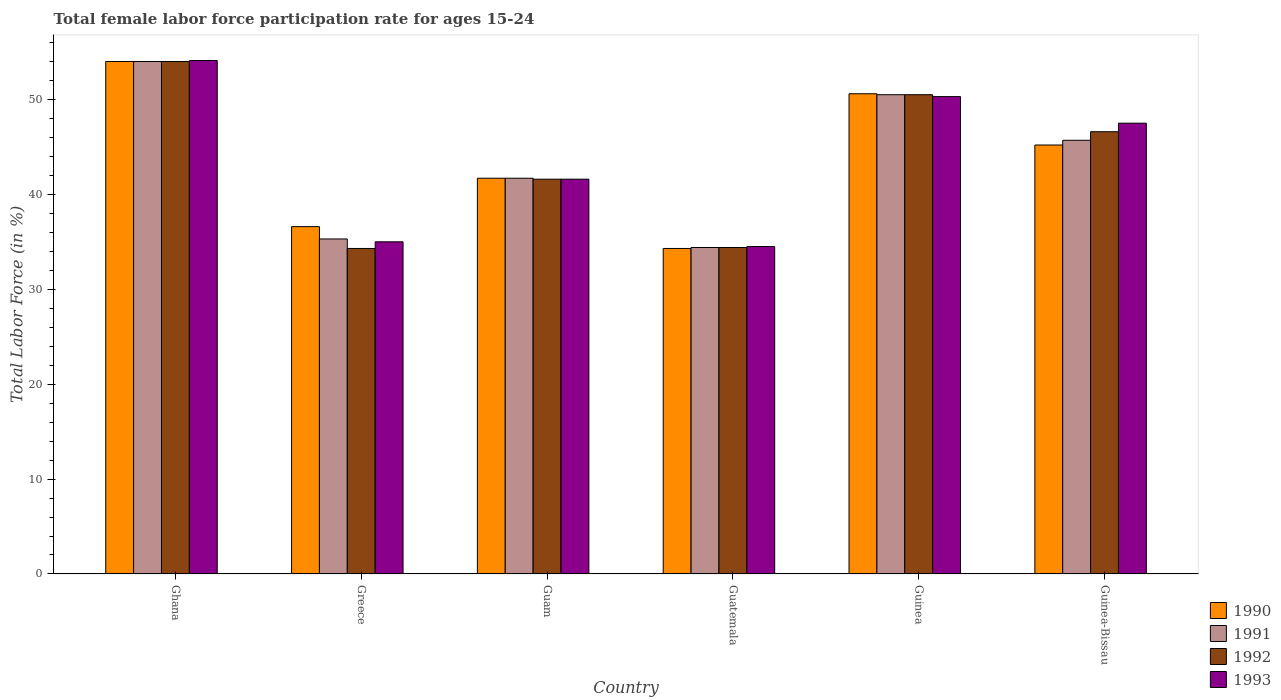How many bars are there on the 1st tick from the left?
Keep it short and to the point. 4. What is the female labor force participation rate in 1992 in Greece?
Ensure brevity in your answer.  34.3. Across all countries, what is the maximum female labor force participation rate in 1991?
Provide a short and direct response. 54. Across all countries, what is the minimum female labor force participation rate in 1990?
Give a very brief answer. 34.3. In which country was the female labor force participation rate in 1990 minimum?
Offer a terse response. Guatemala. What is the total female labor force participation rate in 1990 in the graph?
Offer a very short reply. 262.4. What is the difference between the female labor force participation rate in 1993 in Greece and that in Guam?
Offer a terse response. -6.6. What is the difference between the female labor force participation rate in 1990 in Guatemala and the female labor force participation rate in 1991 in Guinea-Bissau?
Provide a succinct answer. -11.4. What is the average female labor force participation rate in 1991 per country?
Your answer should be compact. 43.6. What is the difference between the female labor force participation rate of/in 1991 and female labor force participation rate of/in 1993 in Guatemala?
Give a very brief answer. -0.1. In how many countries, is the female labor force participation rate in 1993 greater than 46 %?
Keep it short and to the point. 3. What is the ratio of the female labor force participation rate in 1993 in Ghana to that in Guinea-Bissau?
Make the answer very short. 1.14. Is the difference between the female labor force participation rate in 1991 in Guinea and Guinea-Bissau greater than the difference between the female labor force participation rate in 1993 in Guinea and Guinea-Bissau?
Your answer should be compact. Yes. What is the difference between the highest and the second highest female labor force participation rate in 1991?
Your answer should be compact. 4.8. What is the difference between the highest and the lowest female labor force participation rate in 1991?
Offer a very short reply. 19.6. What does the 2nd bar from the right in Guinea-Bissau represents?
Ensure brevity in your answer.  1992. How many bars are there?
Ensure brevity in your answer.  24. Are all the bars in the graph horizontal?
Your answer should be very brief. No. Does the graph contain any zero values?
Give a very brief answer. No. Does the graph contain grids?
Give a very brief answer. No. What is the title of the graph?
Provide a succinct answer. Total female labor force participation rate for ages 15-24. Does "1971" appear as one of the legend labels in the graph?
Your answer should be compact. No. What is the label or title of the Y-axis?
Your answer should be very brief. Total Labor Force (in %). What is the Total Labor Force (in %) in 1991 in Ghana?
Offer a terse response. 54. What is the Total Labor Force (in %) of 1992 in Ghana?
Your response must be concise. 54. What is the Total Labor Force (in %) of 1993 in Ghana?
Ensure brevity in your answer.  54.1. What is the Total Labor Force (in %) in 1990 in Greece?
Make the answer very short. 36.6. What is the Total Labor Force (in %) in 1991 in Greece?
Your answer should be compact. 35.3. What is the Total Labor Force (in %) in 1992 in Greece?
Offer a very short reply. 34.3. What is the Total Labor Force (in %) of 1993 in Greece?
Keep it short and to the point. 35. What is the Total Labor Force (in %) in 1990 in Guam?
Your answer should be compact. 41.7. What is the Total Labor Force (in %) of 1991 in Guam?
Make the answer very short. 41.7. What is the Total Labor Force (in %) in 1992 in Guam?
Make the answer very short. 41.6. What is the Total Labor Force (in %) in 1993 in Guam?
Your response must be concise. 41.6. What is the Total Labor Force (in %) in 1990 in Guatemala?
Keep it short and to the point. 34.3. What is the Total Labor Force (in %) in 1991 in Guatemala?
Your answer should be very brief. 34.4. What is the Total Labor Force (in %) of 1992 in Guatemala?
Give a very brief answer. 34.4. What is the Total Labor Force (in %) of 1993 in Guatemala?
Your response must be concise. 34.5. What is the Total Labor Force (in %) of 1990 in Guinea?
Give a very brief answer. 50.6. What is the Total Labor Force (in %) in 1991 in Guinea?
Keep it short and to the point. 50.5. What is the Total Labor Force (in %) of 1992 in Guinea?
Your answer should be compact. 50.5. What is the Total Labor Force (in %) of 1993 in Guinea?
Offer a terse response. 50.3. What is the Total Labor Force (in %) of 1990 in Guinea-Bissau?
Offer a terse response. 45.2. What is the Total Labor Force (in %) in 1991 in Guinea-Bissau?
Offer a terse response. 45.7. What is the Total Labor Force (in %) in 1992 in Guinea-Bissau?
Your answer should be very brief. 46.6. What is the Total Labor Force (in %) of 1993 in Guinea-Bissau?
Your response must be concise. 47.5. Across all countries, what is the maximum Total Labor Force (in %) of 1990?
Your answer should be very brief. 54. Across all countries, what is the maximum Total Labor Force (in %) in 1993?
Your response must be concise. 54.1. Across all countries, what is the minimum Total Labor Force (in %) in 1990?
Give a very brief answer. 34.3. Across all countries, what is the minimum Total Labor Force (in %) of 1991?
Ensure brevity in your answer.  34.4. Across all countries, what is the minimum Total Labor Force (in %) of 1992?
Make the answer very short. 34.3. Across all countries, what is the minimum Total Labor Force (in %) of 1993?
Ensure brevity in your answer.  34.5. What is the total Total Labor Force (in %) of 1990 in the graph?
Offer a very short reply. 262.4. What is the total Total Labor Force (in %) in 1991 in the graph?
Your response must be concise. 261.6. What is the total Total Labor Force (in %) in 1992 in the graph?
Keep it short and to the point. 261.4. What is the total Total Labor Force (in %) in 1993 in the graph?
Offer a terse response. 263. What is the difference between the Total Labor Force (in %) in 1992 in Ghana and that in Greece?
Provide a short and direct response. 19.7. What is the difference between the Total Labor Force (in %) of 1993 in Ghana and that in Greece?
Your response must be concise. 19.1. What is the difference between the Total Labor Force (in %) in 1990 in Ghana and that in Guam?
Ensure brevity in your answer.  12.3. What is the difference between the Total Labor Force (in %) of 1991 in Ghana and that in Guam?
Make the answer very short. 12.3. What is the difference between the Total Labor Force (in %) in 1992 in Ghana and that in Guam?
Provide a succinct answer. 12.4. What is the difference between the Total Labor Force (in %) in 1993 in Ghana and that in Guam?
Provide a short and direct response. 12.5. What is the difference between the Total Labor Force (in %) of 1991 in Ghana and that in Guatemala?
Keep it short and to the point. 19.6. What is the difference between the Total Labor Force (in %) in 1992 in Ghana and that in Guatemala?
Give a very brief answer. 19.6. What is the difference between the Total Labor Force (in %) in 1993 in Ghana and that in Guatemala?
Your answer should be very brief. 19.6. What is the difference between the Total Labor Force (in %) of 1993 in Ghana and that in Guinea?
Your response must be concise. 3.8. What is the difference between the Total Labor Force (in %) of 1990 in Greece and that in Guam?
Provide a succinct answer. -5.1. What is the difference between the Total Labor Force (in %) in 1991 in Greece and that in Guam?
Ensure brevity in your answer.  -6.4. What is the difference between the Total Labor Force (in %) in 1992 in Greece and that in Guam?
Offer a very short reply. -7.3. What is the difference between the Total Labor Force (in %) of 1990 in Greece and that in Guatemala?
Give a very brief answer. 2.3. What is the difference between the Total Labor Force (in %) in 1991 in Greece and that in Guatemala?
Provide a succinct answer. 0.9. What is the difference between the Total Labor Force (in %) of 1993 in Greece and that in Guatemala?
Provide a short and direct response. 0.5. What is the difference between the Total Labor Force (in %) of 1991 in Greece and that in Guinea?
Offer a very short reply. -15.2. What is the difference between the Total Labor Force (in %) in 1992 in Greece and that in Guinea?
Offer a very short reply. -16.2. What is the difference between the Total Labor Force (in %) in 1993 in Greece and that in Guinea?
Make the answer very short. -15.3. What is the difference between the Total Labor Force (in %) of 1990 in Greece and that in Guinea-Bissau?
Keep it short and to the point. -8.6. What is the difference between the Total Labor Force (in %) of 1991 in Greece and that in Guinea-Bissau?
Offer a terse response. -10.4. What is the difference between the Total Labor Force (in %) in 1992 in Greece and that in Guinea-Bissau?
Provide a short and direct response. -12.3. What is the difference between the Total Labor Force (in %) in 1993 in Greece and that in Guinea-Bissau?
Offer a terse response. -12.5. What is the difference between the Total Labor Force (in %) of 1990 in Guam and that in Guatemala?
Give a very brief answer. 7.4. What is the difference between the Total Labor Force (in %) of 1992 in Guam and that in Guatemala?
Your answer should be very brief. 7.2. What is the difference between the Total Labor Force (in %) in 1992 in Guam and that in Guinea?
Provide a succinct answer. -8.9. What is the difference between the Total Labor Force (in %) of 1993 in Guam and that in Guinea?
Your response must be concise. -8.7. What is the difference between the Total Labor Force (in %) of 1990 in Guatemala and that in Guinea?
Keep it short and to the point. -16.3. What is the difference between the Total Labor Force (in %) in 1991 in Guatemala and that in Guinea?
Your response must be concise. -16.1. What is the difference between the Total Labor Force (in %) in 1992 in Guatemala and that in Guinea?
Keep it short and to the point. -16.1. What is the difference between the Total Labor Force (in %) of 1993 in Guatemala and that in Guinea?
Give a very brief answer. -15.8. What is the difference between the Total Labor Force (in %) of 1990 in Guinea and that in Guinea-Bissau?
Your answer should be very brief. 5.4. What is the difference between the Total Labor Force (in %) in 1991 in Guinea and that in Guinea-Bissau?
Provide a short and direct response. 4.8. What is the difference between the Total Labor Force (in %) of 1993 in Guinea and that in Guinea-Bissau?
Your answer should be compact. 2.8. What is the difference between the Total Labor Force (in %) of 1990 in Ghana and the Total Labor Force (in %) of 1992 in Greece?
Your answer should be compact. 19.7. What is the difference between the Total Labor Force (in %) of 1991 in Ghana and the Total Labor Force (in %) of 1992 in Greece?
Make the answer very short. 19.7. What is the difference between the Total Labor Force (in %) in 1990 in Ghana and the Total Labor Force (in %) in 1993 in Guam?
Ensure brevity in your answer.  12.4. What is the difference between the Total Labor Force (in %) of 1991 in Ghana and the Total Labor Force (in %) of 1993 in Guam?
Give a very brief answer. 12.4. What is the difference between the Total Labor Force (in %) of 1992 in Ghana and the Total Labor Force (in %) of 1993 in Guam?
Provide a succinct answer. 12.4. What is the difference between the Total Labor Force (in %) in 1990 in Ghana and the Total Labor Force (in %) in 1991 in Guatemala?
Your answer should be compact. 19.6. What is the difference between the Total Labor Force (in %) of 1990 in Ghana and the Total Labor Force (in %) of 1992 in Guatemala?
Provide a succinct answer. 19.6. What is the difference between the Total Labor Force (in %) of 1991 in Ghana and the Total Labor Force (in %) of 1992 in Guatemala?
Provide a short and direct response. 19.6. What is the difference between the Total Labor Force (in %) of 1991 in Ghana and the Total Labor Force (in %) of 1993 in Guatemala?
Make the answer very short. 19.5. What is the difference between the Total Labor Force (in %) in 1992 in Ghana and the Total Labor Force (in %) in 1993 in Guatemala?
Keep it short and to the point. 19.5. What is the difference between the Total Labor Force (in %) of 1990 in Ghana and the Total Labor Force (in %) of 1991 in Guinea?
Offer a terse response. 3.5. What is the difference between the Total Labor Force (in %) in 1990 in Ghana and the Total Labor Force (in %) in 1993 in Guinea?
Keep it short and to the point. 3.7. What is the difference between the Total Labor Force (in %) of 1991 in Ghana and the Total Labor Force (in %) of 1993 in Guinea?
Your response must be concise. 3.7. What is the difference between the Total Labor Force (in %) of 1990 in Ghana and the Total Labor Force (in %) of 1992 in Guinea-Bissau?
Offer a very short reply. 7.4. What is the difference between the Total Labor Force (in %) in 1991 in Ghana and the Total Labor Force (in %) in 1992 in Guinea-Bissau?
Give a very brief answer. 7.4. What is the difference between the Total Labor Force (in %) in 1991 in Ghana and the Total Labor Force (in %) in 1993 in Guinea-Bissau?
Ensure brevity in your answer.  6.5. What is the difference between the Total Labor Force (in %) in 1992 in Greece and the Total Labor Force (in %) in 1993 in Guam?
Make the answer very short. -7.3. What is the difference between the Total Labor Force (in %) in 1990 in Greece and the Total Labor Force (in %) in 1992 in Guatemala?
Your answer should be compact. 2.2. What is the difference between the Total Labor Force (in %) in 1990 in Greece and the Total Labor Force (in %) in 1993 in Guatemala?
Provide a short and direct response. 2.1. What is the difference between the Total Labor Force (in %) in 1990 in Greece and the Total Labor Force (in %) in 1993 in Guinea?
Your answer should be compact. -13.7. What is the difference between the Total Labor Force (in %) in 1991 in Greece and the Total Labor Force (in %) in 1992 in Guinea?
Provide a succinct answer. -15.2. What is the difference between the Total Labor Force (in %) of 1990 in Greece and the Total Labor Force (in %) of 1992 in Guinea-Bissau?
Give a very brief answer. -10. What is the difference between the Total Labor Force (in %) of 1990 in Guam and the Total Labor Force (in %) of 1993 in Guatemala?
Make the answer very short. 7.2. What is the difference between the Total Labor Force (in %) in 1991 in Guam and the Total Labor Force (in %) in 1993 in Guatemala?
Provide a short and direct response. 7.2. What is the difference between the Total Labor Force (in %) of 1990 in Guam and the Total Labor Force (in %) of 1991 in Guinea?
Your answer should be very brief. -8.8. What is the difference between the Total Labor Force (in %) in 1990 in Guam and the Total Labor Force (in %) in 1992 in Guinea?
Ensure brevity in your answer.  -8.8. What is the difference between the Total Labor Force (in %) of 1991 in Guam and the Total Labor Force (in %) of 1993 in Guinea?
Give a very brief answer. -8.6. What is the difference between the Total Labor Force (in %) of 1990 in Guam and the Total Labor Force (in %) of 1992 in Guinea-Bissau?
Your answer should be very brief. -4.9. What is the difference between the Total Labor Force (in %) of 1990 in Guam and the Total Labor Force (in %) of 1993 in Guinea-Bissau?
Your answer should be very brief. -5.8. What is the difference between the Total Labor Force (in %) in 1991 in Guam and the Total Labor Force (in %) in 1992 in Guinea-Bissau?
Ensure brevity in your answer.  -4.9. What is the difference between the Total Labor Force (in %) of 1991 in Guam and the Total Labor Force (in %) of 1993 in Guinea-Bissau?
Keep it short and to the point. -5.8. What is the difference between the Total Labor Force (in %) of 1990 in Guatemala and the Total Labor Force (in %) of 1991 in Guinea?
Keep it short and to the point. -16.2. What is the difference between the Total Labor Force (in %) in 1990 in Guatemala and the Total Labor Force (in %) in 1992 in Guinea?
Give a very brief answer. -16.2. What is the difference between the Total Labor Force (in %) in 1991 in Guatemala and the Total Labor Force (in %) in 1992 in Guinea?
Your answer should be compact. -16.1. What is the difference between the Total Labor Force (in %) of 1991 in Guatemala and the Total Labor Force (in %) of 1993 in Guinea?
Your answer should be very brief. -15.9. What is the difference between the Total Labor Force (in %) of 1992 in Guatemala and the Total Labor Force (in %) of 1993 in Guinea?
Provide a short and direct response. -15.9. What is the difference between the Total Labor Force (in %) in 1990 in Guatemala and the Total Labor Force (in %) in 1991 in Guinea-Bissau?
Your answer should be very brief. -11.4. What is the difference between the Total Labor Force (in %) of 1990 in Guatemala and the Total Labor Force (in %) of 1992 in Guinea-Bissau?
Provide a succinct answer. -12.3. What is the difference between the Total Labor Force (in %) in 1990 in Guatemala and the Total Labor Force (in %) in 1993 in Guinea-Bissau?
Give a very brief answer. -13.2. What is the difference between the Total Labor Force (in %) of 1991 in Guatemala and the Total Labor Force (in %) of 1993 in Guinea-Bissau?
Your answer should be compact. -13.1. What is the difference between the Total Labor Force (in %) of 1990 in Guinea and the Total Labor Force (in %) of 1991 in Guinea-Bissau?
Give a very brief answer. 4.9. What is the difference between the Total Labor Force (in %) in 1990 in Guinea and the Total Labor Force (in %) in 1992 in Guinea-Bissau?
Ensure brevity in your answer.  4. What is the difference between the Total Labor Force (in %) in 1991 in Guinea and the Total Labor Force (in %) in 1992 in Guinea-Bissau?
Your answer should be compact. 3.9. What is the average Total Labor Force (in %) of 1990 per country?
Give a very brief answer. 43.73. What is the average Total Labor Force (in %) of 1991 per country?
Ensure brevity in your answer.  43.6. What is the average Total Labor Force (in %) in 1992 per country?
Offer a very short reply. 43.57. What is the average Total Labor Force (in %) in 1993 per country?
Offer a very short reply. 43.83. What is the difference between the Total Labor Force (in %) of 1990 and Total Labor Force (in %) of 1993 in Ghana?
Keep it short and to the point. -0.1. What is the difference between the Total Labor Force (in %) in 1991 and Total Labor Force (in %) in 1993 in Ghana?
Your answer should be very brief. -0.1. What is the difference between the Total Labor Force (in %) of 1992 and Total Labor Force (in %) of 1993 in Ghana?
Make the answer very short. -0.1. What is the difference between the Total Labor Force (in %) in 1990 and Total Labor Force (in %) in 1992 in Greece?
Your answer should be very brief. 2.3. What is the difference between the Total Labor Force (in %) in 1992 and Total Labor Force (in %) in 1993 in Greece?
Your answer should be compact. -0.7. What is the difference between the Total Labor Force (in %) in 1990 and Total Labor Force (in %) in 1991 in Guam?
Keep it short and to the point. 0. What is the difference between the Total Labor Force (in %) in 1990 and Total Labor Force (in %) in 1992 in Guam?
Give a very brief answer. 0.1. What is the difference between the Total Labor Force (in %) in 1991 and Total Labor Force (in %) in 1993 in Guam?
Your answer should be very brief. 0.1. What is the difference between the Total Labor Force (in %) of 1990 and Total Labor Force (in %) of 1991 in Guatemala?
Provide a short and direct response. -0.1. What is the difference between the Total Labor Force (in %) in 1990 and Total Labor Force (in %) in 1992 in Guatemala?
Your answer should be compact. -0.1. What is the difference between the Total Labor Force (in %) in 1990 and Total Labor Force (in %) in 1993 in Guatemala?
Provide a succinct answer. -0.2. What is the difference between the Total Labor Force (in %) of 1991 and Total Labor Force (in %) of 1993 in Guatemala?
Ensure brevity in your answer.  -0.1. What is the difference between the Total Labor Force (in %) in 1992 and Total Labor Force (in %) in 1993 in Guatemala?
Your answer should be compact. -0.1. What is the difference between the Total Labor Force (in %) of 1990 and Total Labor Force (in %) of 1993 in Guinea?
Ensure brevity in your answer.  0.3. What is the difference between the Total Labor Force (in %) of 1991 and Total Labor Force (in %) of 1992 in Guinea?
Ensure brevity in your answer.  0. What is the difference between the Total Labor Force (in %) of 1991 and Total Labor Force (in %) of 1993 in Guinea?
Your answer should be very brief. 0.2. What is the difference between the Total Labor Force (in %) of 1992 and Total Labor Force (in %) of 1993 in Guinea?
Give a very brief answer. 0.2. What is the difference between the Total Labor Force (in %) of 1990 and Total Labor Force (in %) of 1993 in Guinea-Bissau?
Offer a very short reply. -2.3. What is the difference between the Total Labor Force (in %) in 1991 and Total Labor Force (in %) in 1993 in Guinea-Bissau?
Ensure brevity in your answer.  -1.8. What is the ratio of the Total Labor Force (in %) of 1990 in Ghana to that in Greece?
Offer a very short reply. 1.48. What is the ratio of the Total Labor Force (in %) of 1991 in Ghana to that in Greece?
Provide a short and direct response. 1.53. What is the ratio of the Total Labor Force (in %) of 1992 in Ghana to that in Greece?
Ensure brevity in your answer.  1.57. What is the ratio of the Total Labor Force (in %) in 1993 in Ghana to that in Greece?
Your response must be concise. 1.55. What is the ratio of the Total Labor Force (in %) of 1990 in Ghana to that in Guam?
Your answer should be very brief. 1.29. What is the ratio of the Total Labor Force (in %) in 1991 in Ghana to that in Guam?
Provide a succinct answer. 1.29. What is the ratio of the Total Labor Force (in %) in 1992 in Ghana to that in Guam?
Your response must be concise. 1.3. What is the ratio of the Total Labor Force (in %) in 1993 in Ghana to that in Guam?
Make the answer very short. 1.3. What is the ratio of the Total Labor Force (in %) of 1990 in Ghana to that in Guatemala?
Offer a terse response. 1.57. What is the ratio of the Total Labor Force (in %) in 1991 in Ghana to that in Guatemala?
Your response must be concise. 1.57. What is the ratio of the Total Labor Force (in %) in 1992 in Ghana to that in Guatemala?
Provide a short and direct response. 1.57. What is the ratio of the Total Labor Force (in %) of 1993 in Ghana to that in Guatemala?
Your answer should be compact. 1.57. What is the ratio of the Total Labor Force (in %) in 1990 in Ghana to that in Guinea?
Your answer should be compact. 1.07. What is the ratio of the Total Labor Force (in %) in 1991 in Ghana to that in Guinea?
Make the answer very short. 1.07. What is the ratio of the Total Labor Force (in %) of 1992 in Ghana to that in Guinea?
Your answer should be compact. 1.07. What is the ratio of the Total Labor Force (in %) in 1993 in Ghana to that in Guinea?
Keep it short and to the point. 1.08. What is the ratio of the Total Labor Force (in %) of 1990 in Ghana to that in Guinea-Bissau?
Your answer should be compact. 1.19. What is the ratio of the Total Labor Force (in %) of 1991 in Ghana to that in Guinea-Bissau?
Provide a succinct answer. 1.18. What is the ratio of the Total Labor Force (in %) in 1992 in Ghana to that in Guinea-Bissau?
Your response must be concise. 1.16. What is the ratio of the Total Labor Force (in %) in 1993 in Ghana to that in Guinea-Bissau?
Keep it short and to the point. 1.14. What is the ratio of the Total Labor Force (in %) in 1990 in Greece to that in Guam?
Your answer should be compact. 0.88. What is the ratio of the Total Labor Force (in %) of 1991 in Greece to that in Guam?
Your answer should be compact. 0.85. What is the ratio of the Total Labor Force (in %) of 1992 in Greece to that in Guam?
Your answer should be compact. 0.82. What is the ratio of the Total Labor Force (in %) of 1993 in Greece to that in Guam?
Provide a short and direct response. 0.84. What is the ratio of the Total Labor Force (in %) of 1990 in Greece to that in Guatemala?
Your answer should be compact. 1.07. What is the ratio of the Total Labor Force (in %) in 1991 in Greece to that in Guatemala?
Your answer should be very brief. 1.03. What is the ratio of the Total Labor Force (in %) of 1992 in Greece to that in Guatemala?
Provide a succinct answer. 1. What is the ratio of the Total Labor Force (in %) of 1993 in Greece to that in Guatemala?
Your answer should be very brief. 1.01. What is the ratio of the Total Labor Force (in %) of 1990 in Greece to that in Guinea?
Offer a terse response. 0.72. What is the ratio of the Total Labor Force (in %) in 1991 in Greece to that in Guinea?
Make the answer very short. 0.7. What is the ratio of the Total Labor Force (in %) in 1992 in Greece to that in Guinea?
Make the answer very short. 0.68. What is the ratio of the Total Labor Force (in %) in 1993 in Greece to that in Guinea?
Ensure brevity in your answer.  0.7. What is the ratio of the Total Labor Force (in %) of 1990 in Greece to that in Guinea-Bissau?
Offer a terse response. 0.81. What is the ratio of the Total Labor Force (in %) in 1991 in Greece to that in Guinea-Bissau?
Your response must be concise. 0.77. What is the ratio of the Total Labor Force (in %) of 1992 in Greece to that in Guinea-Bissau?
Your answer should be very brief. 0.74. What is the ratio of the Total Labor Force (in %) of 1993 in Greece to that in Guinea-Bissau?
Your answer should be very brief. 0.74. What is the ratio of the Total Labor Force (in %) of 1990 in Guam to that in Guatemala?
Provide a succinct answer. 1.22. What is the ratio of the Total Labor Force (in %) of 1991 in Guam to that in Guatemala?
Your answer should be compact. 1.21. What is the ratio of the Total Labor Force (in %) in 1992 in Guam to that in Guatemala?
Offer a very short reply. 1.21. What is the ratio of the Total Labor Force (in %) in 1993 in Guam to that in Guatemala?
Keep it short and to the point. 1.21. What is the ratio of the Total Labor Force (in %) of 1990 in Guam to that in Guinea?
Keep it short and to the point. 0.82. What is the ratio of the Total Labor Force (in %) in 1991 in Guam to that in Guinea?
Your answer should be very brief. 0.83. What is the ratio of the Total Labor Force (in %) of 1992 in Guam to that in Guinea?
Keep it short and to the point. 0.82. What is the ratio of the Total Labor Force (in %) in 1993 in Guam to that in Guinea?
Your answer should be compact. 0.83. What is the ratio of the Total Labor Force (in %) of 1990 in Guam to that in Guinea-Bissau?
Give a very brief answer. 0.92. What is the ratio of the Total Labor Force (in %) of 1991 in Guam to that in Guinea-Bissau?
Offer a terse response. 0.91. What is the ratio of the Total Labor Force (in %) of 1992 in Guam to that in Guinea-Bissau?
Your answer should be compact. 0.89. What is the ratio of the Total Labor Force (in %) in 1993 in Guam to that in Guinea-Bissau?
Give a very brief answer. 0.88. What is the ratio of the Total Labor Force (in %) in 1990 in Guatemala to that in Guinea?
Give a very brief answer. 0.68. What is the ratio of the Total Labor Force (in %) of 1991 in Guatemala to that in Guinea?
Provide a short and direct response. 0.68. What is the ratio of the Total Labor Force (in %) in 1992 in Guatemala to that in Guinea?
Ensure brevity in your answer.  0.68. What is the ratio of the Total Labor Force (in %) of 1993 in Guatemala to that in Guinea?
Your answer should be very brief. 0.69. What is the ratio of the Total Labor Force (in %) of 1990 in Guatemala to that in Guinea-Bissau?
Provide a short and direct response. 0.76. What is the ratio of the Total Labor Force (in %) in 1991 in Guatemala to that in Guinea-Bissau?
Offer a terse response. 0.75. What is the ratio of the Total Labor Force (in %) in 1992 in Guatemala to that in Guinea-Bissau?
Your answer should be very brief. 0.74. What is the ratio of the Total Labor Force (in %) of 1993 in Guatemala to that in Guinea-Bissau?
Make the answer very short. 0.73. What is the ratio of the Total Labor Force (in %) in 1990 in Guinea to that in Guinea-Bissau?
Provide a succinct answer. 1.12. What is the ratio of the Total Labor Force (in %) in 1991 in Guinea to that in Guinea-Bissau?
Provide a short and direct response. 1.1. What is the ratio of the Total Labor Force (in %) of 1992 in Guinea to that in Guinea-Bissau?
Provide a short and direct response. 1.08. What is the ratio of the Total Labor Force (in %) of 1993 in Guinea to that in Guinea-Bissau?
Provide a short and direct response. 1.06. What is the difference between the highest and the second highest Total Labor Force (in %) in 1991?
Offer a terse response. 3.5. What is the difference between the highest and the second highest Total Labor Force (in %) of 1993?
Keep it short and to the point. 3.8. What is the difference between the highest and the lowest Total Labor Force (in %) in 1990?
Offer a very short reply. 19.7. What is the difference between the highest and the lowest Total Labor Force (in %) in 1991?
Give a very brief answer. 19.6. What is the difference between the highest and the lowest Total Labor Force (in %) in 1992?
Your answer should be very brief. 19.7. What is the difference between the highest and the lowest Total Labor Force (in %) in 1993?
Offer a very short reply. 19.6. 